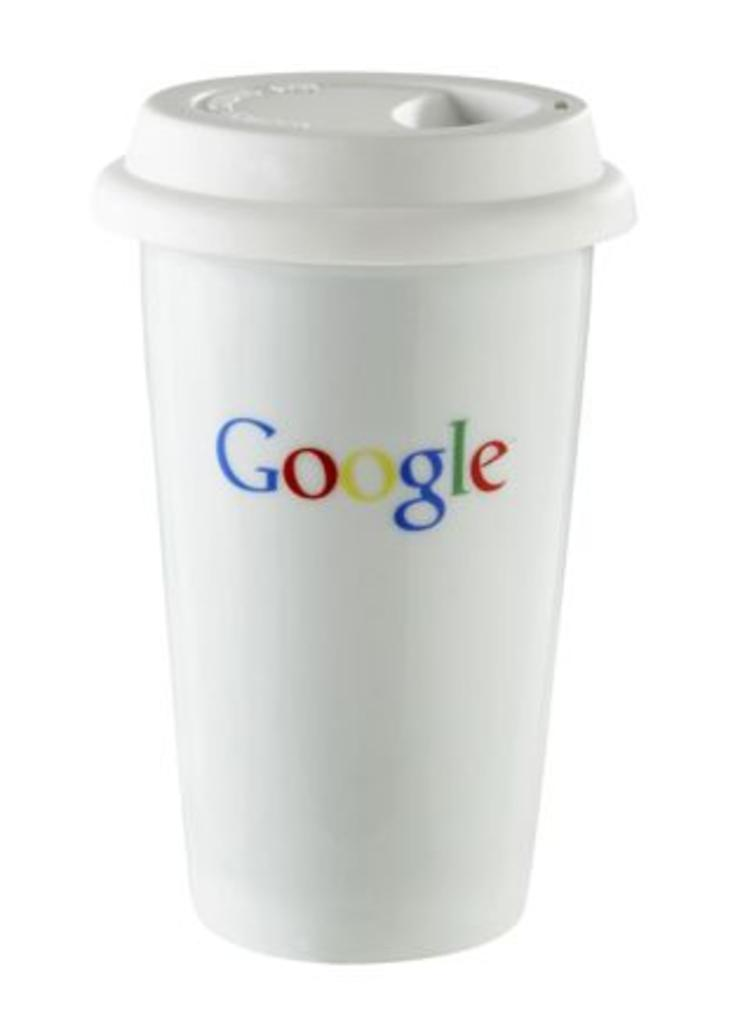<image>
Summarize the visual content of the image. A disposable cup displays the multi-colored Google logo on its side. 